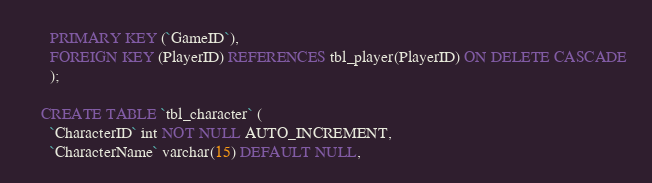Convert code to text. <code><loc_0><loc_0><loc_500><loc_500><_SQL_>	  PRIMARY KEY (`GameID`),
      FOREIGN KEY (PlayerID) REFERENCES tbl_player(PlayerID) ON DELETE CASCADE
	  );  
      
    CREATE TABLE `tbl_character` (
	  `CharacterID` int NOT NULL AUTO_INCREMENT,
	  `CharacterName` varchar(15) DEFAULT NULL,</code> 